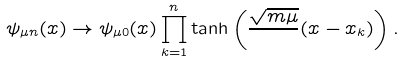<formula> <loc_0><loc_0><loc_500><loc_500>\psi _ { \mu n } ( x ) \to \psi _ { \mu 0 } ( x ) \prod _ { k = 1 } ^ { n } \tanh \left ( \frac { \sqrt { m \mu } } { } ( x - x _ { k } ) \right ) .</formula> 